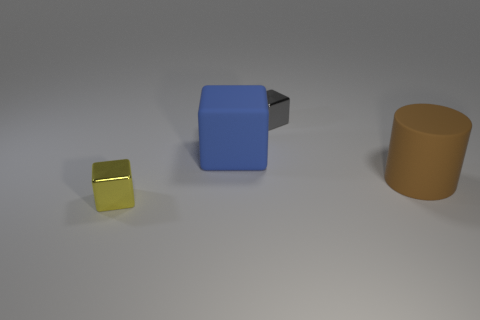There is a brown cylinder that is right of the block in front of the rubber thing to the left of the gray shiny thing; what size is it?
Ensure brevity in your answer.  Large. What size is the matte cylinder?
Ensure brevity in your answer.  Large. There is a tiny shiny thing that is right of the tiny block in front of the gray shiny block; is there a big brown cylinder behind it?
Your answer should be compact. No. What number of big things are either blue rubber cubes or brown matte things?
Make the answer very short. 2. Are there any other things that are the same color as the rubber cylinder?
Offer a very short reply. No. Do the shiny thing that is to the left of the gray cube and the large brown thing have the same size?
Keep it short and to the point. No. What color is the cube that is in front of the rubber object to the left of the metal object right of the big block?
Make the answer very short. Yellow. The matte cube is what color?
Offer a very short reply. Blue. Does the big matte cube have the same color as the large cylinder?
Offer a terse response. No. Is the material of the tiny object right of the large blue cube the same as the blue thing that is behind the brown cylinder?
Provide a succinct answer. No. 